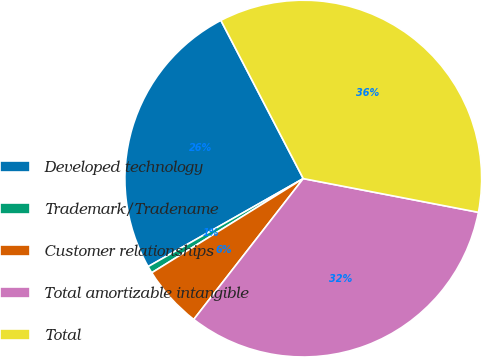<chart> <loc_0><loc_0><loc_500><loc_500><pie_chart><fcel>Developed technology<fcel>Trademark/Tradename<fcel>Customer relationships<fcel>Total amortizable intangible<fcel>Total<nl><fcel>25.57%<fcel>0.64%<fcel>5.63%<fcel>32.49%<fcel>35.67%<nl></chart> 